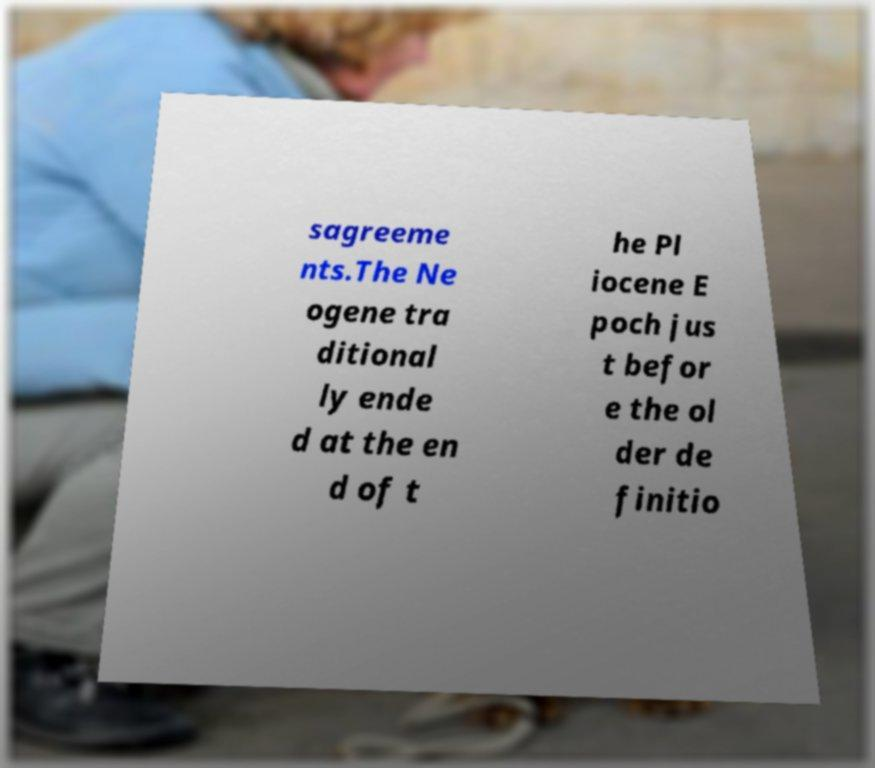Can you read and provide the text displayed in the image?This photo seems to have some interesting text. Can you extract and type it out for me? sagreeme nts.The Ne ogene tra ditional ly ende d at the en d of t he Pl iocene E poch jus t befor e the ol der de finitio 